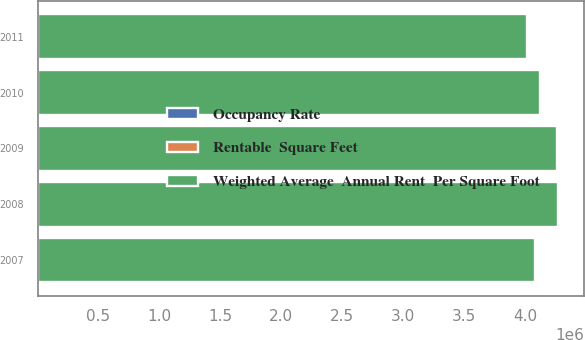<chart> <loc_0><loc_0><loc_500><loc_500><stacked_bar_chart><ecel><fcel>2011<fcel>2010<fcel>2009<fcel>2008<fcel>2007<nl><fcel>Weighted Average  Annual Rent  Per Square Foot<fcel>4.014e+06<fcel>4.122e+06<fcel>4.263e+06<fcel>4.274e+06<fcel>4.085e+06<nl><fcel>Rentable  Square Feet<fcel>83<fcel>93.8<fcel>89.9<fcel>93.5<fcel>93.5<nl><fcel>Occupancy Rate<fcel>31.53<fcel>31.53<fcel>31.66<fcel>30.93<fcel>30.55<nl></chart> 